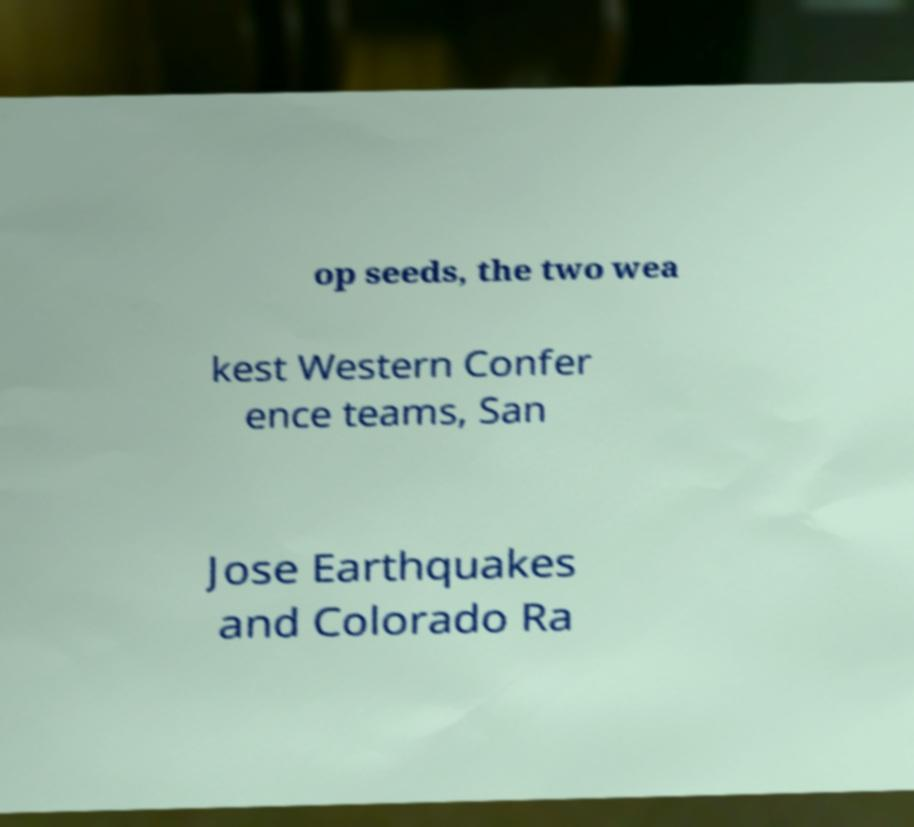Can you accurately transcribe the text from the provided image for me? op seeds, the two wea kest Western Confer ence teams, San Jose Earthquakes and Colorado Ra 